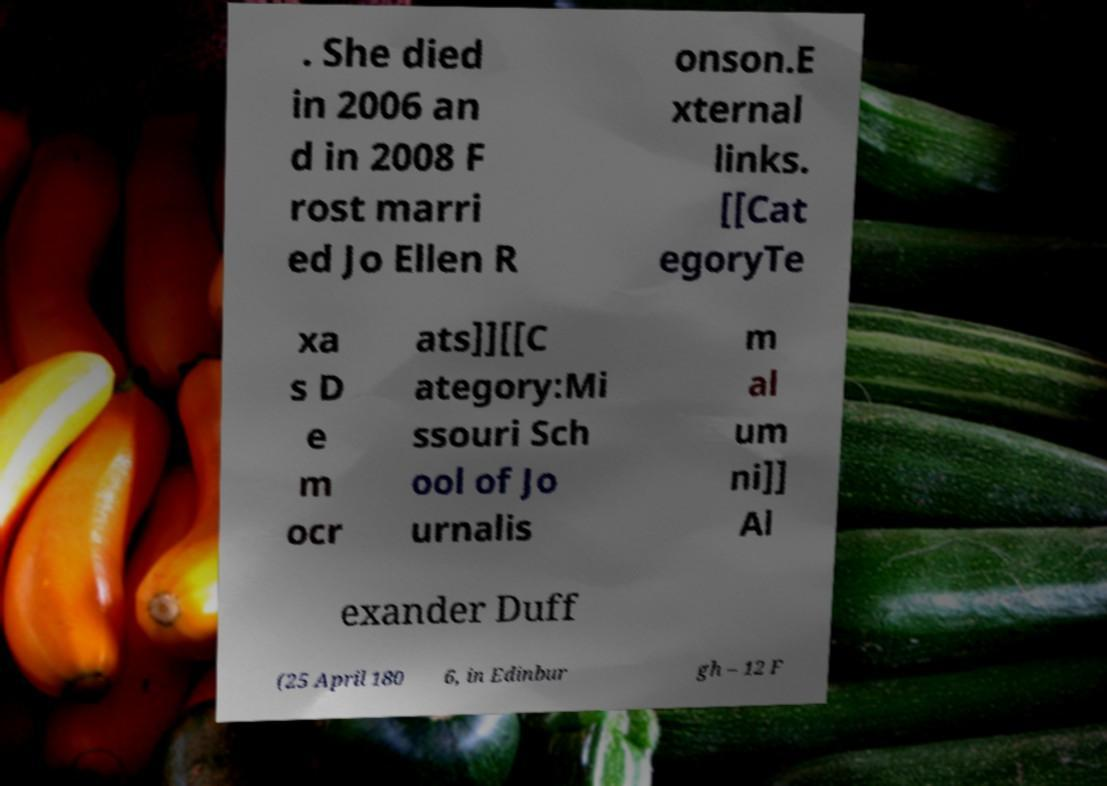Can you read and provide the text displayed in the image?This photo seems to have some interesting text. Can you extract and type it out for me? . She died in 2006 an d in 2008 F rost marri ed Jo Ellen R onson.E xternal links. [[Cat egoryTe xa s D e m ocr ats]][[C ategory:Mi ssouri Sch ool of Jo urnalis m al um ni]] Al exander Duff (25 April 180 6, in Edinbur gh – 12 F 